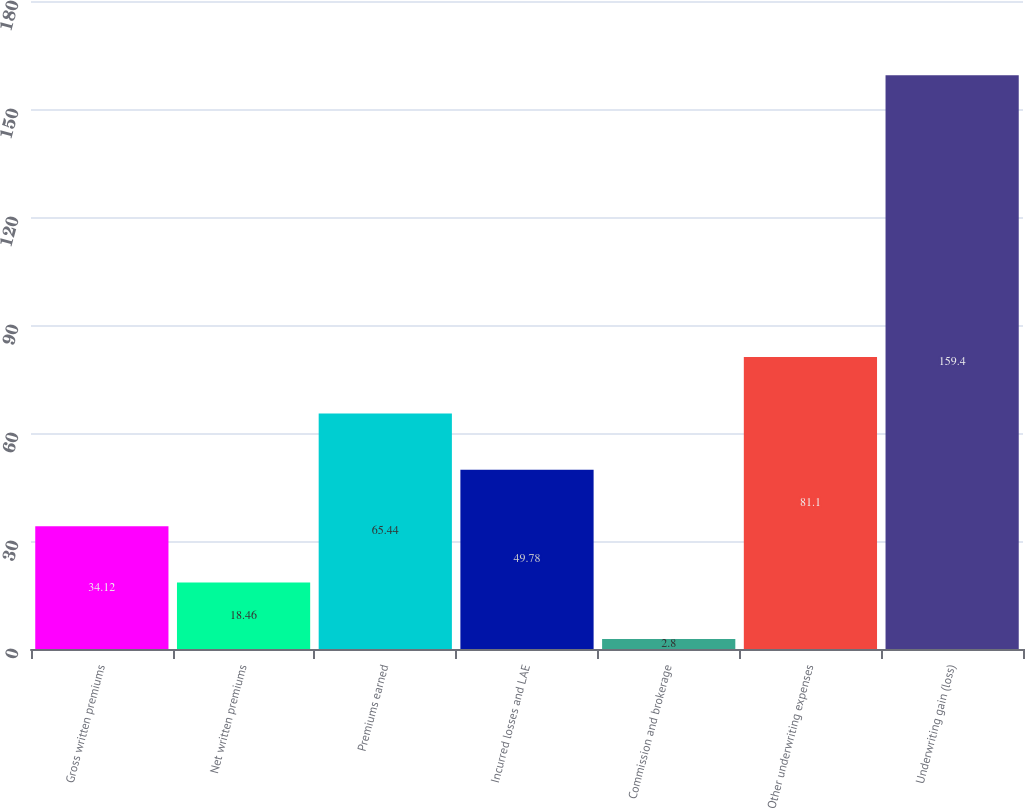Convert chart. <chart><loc_0><loc_0><loc_500><loc_500><bar_chart><fcel>Gross written premiums<fcel>Net written premiums<fcel>Premiums earned<fcel>Incurred losses and LAE<fcel>Commission and brokerage<fcel>Other underwriting expenses<fcel>Underwriting gain (loss)<nl><fcel>34.12<fcel>18.46<fcel>65.44<fcel>49.78<fcel>2.8<fcel>81.1<fcel>159.4<nl></chart> 